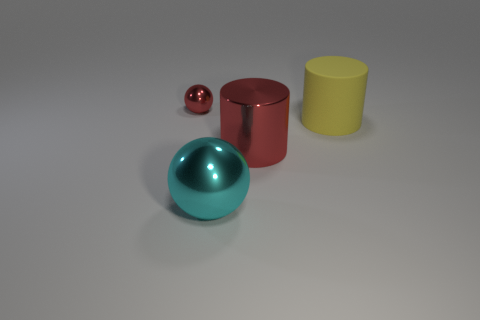What is the color of the object that is on the left side of the matte cylinder and to the right of the cyan thing?
Offer a very short reply. Red. Do the red object that is behind the yellow cylinder and the yellow thing in front of the tiny shiny ball have the same material?
Make the answer very short. No. There is a cylinder behind the red object in front of the small metallic ball; what is it made of?
Provide a short and direct response. Rubber. There is a object in front of the shiny cylinder; what material is it?
Make the answer very short. Metal. Do the small metal thing and the metallic cylinder have the same color?
Your answer should be compact. Yes. What material is the large yellow thing that is to the right of the big thing that is in front of the red thing that is to the right of the tiny metallic sphere made of?
Give a very brief answer. Rubber. The red object that is the same size as the cyan metallic ball is what shape?
Give a very brief answer. Cylinder. Does the yellow cylinder have the same material as the big red thing?
Your response must be concise. No. There is a object that is the same color as the metallic cylinder; what is its shape?
Make the answer very short. Sphere. Do the cylinder that is in front of the yellow rubber thing and the tiny object have the same color?
Provide a succinct answer. Yes. 